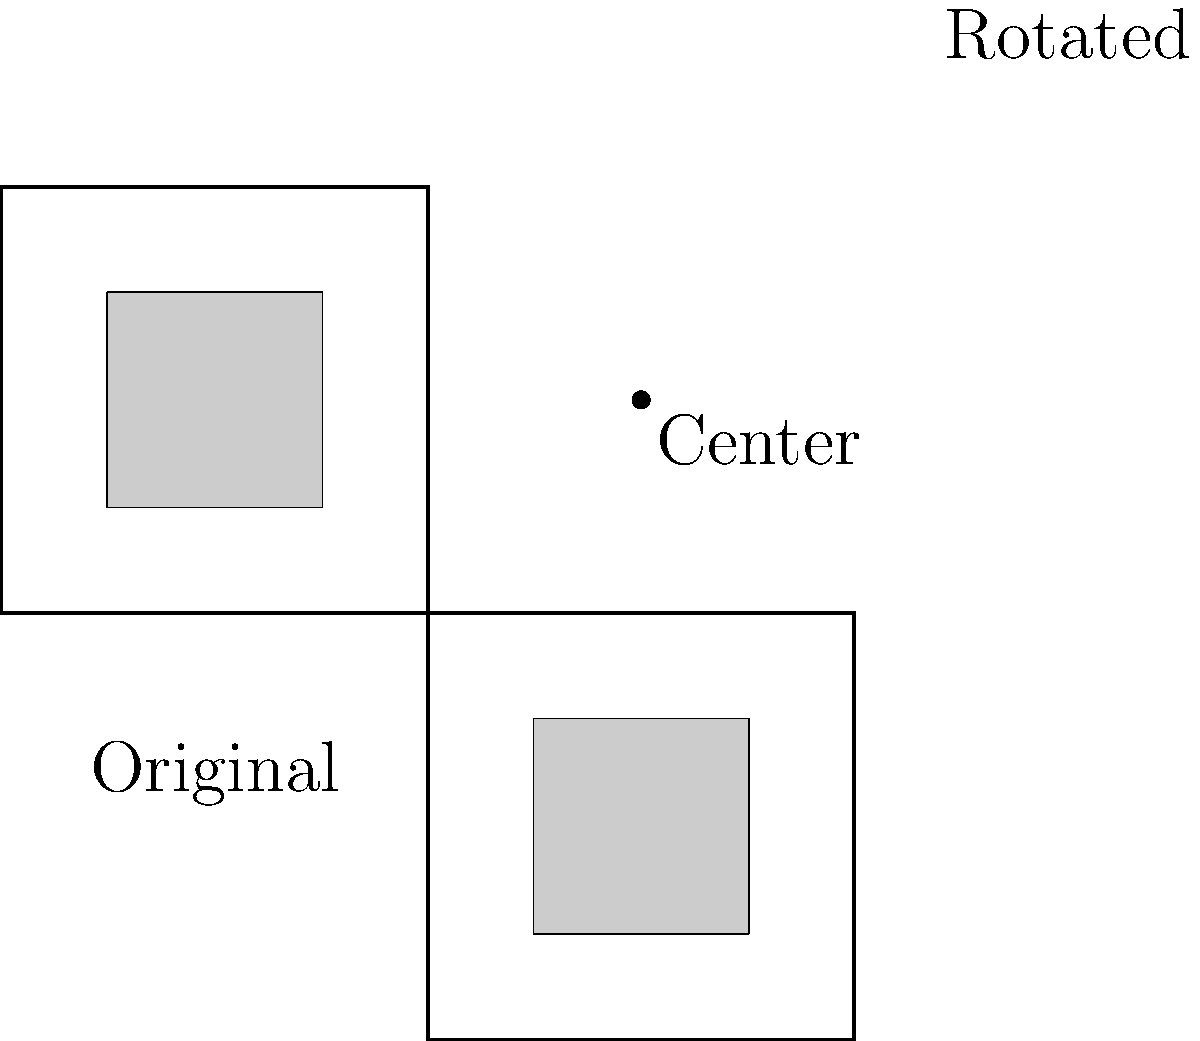As you're designing a new quilt pattern for your local quilting club, you decide to incorporate a rotational element. The original pattern includes a square within a larger square, as shown in the "Original" diagram. If you rotate this pattern 90 degrees clockwise around the center point marked in the image, which of the following statements is true about the rotated pattern?

A) The inner square will be above the center of rotation
B) The inner square will be below the center of rotation
C) The inner square will be to the left of the center of rotation
D) The inner square will be to the right of the center of rotation Let's approach this step-by-step:

1) First, observe the original pattern. The inner square is positioned in the bottom-left quadrant of the larger square.

2) The center of rotation is marked between the original and rotated patterns.

3) A 90-degree clockwise rotation means we're turning the entire pattern 90 degrees to the right around this center point.

4) To visualize this, imagine grabbing the bottom-left corner of the original square and swinging it around to the top-left corner of the rotated position.

5) As we do this, the inner square, which started in the bottom-left, will end up in the bottom-right quadrant of the rotated larger square.

6) Looking at the rotated pattern, we can see that the inner square is indeed to the right of the center of rotation.

Therefore, the correct statement is that after rotation, the inner square will be to the right of the center of rotation.
Answer: D 